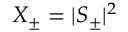<formula> <loc_0><loc_0><loc_500><loc_500>X _ { \pm } = | S _ { \pm } | ^ { 2 }</formula> 